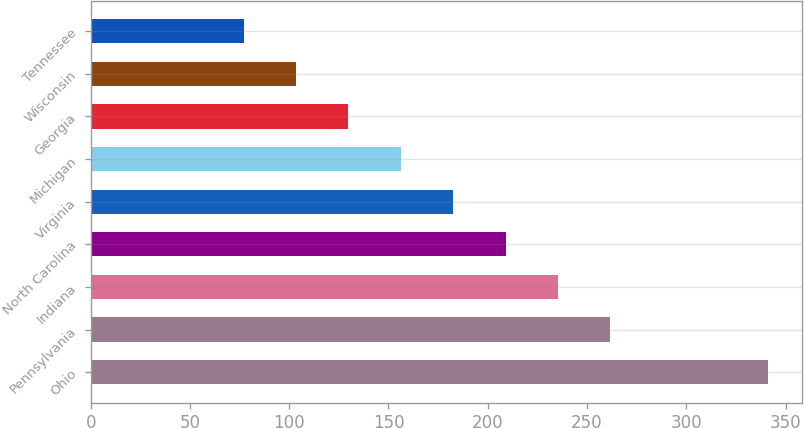Convert chart to OTSL. <chart><loc_0><loc_0><loc_500><loc_500><bar_chart><fcel>Ohio<fcel>Pennsylvania<fcel>Indiana<fcel>North Carolina<fcel>Virginia<fcel>Michigan<fcel>Georgia<fcel>Wisconsin<fcel>Tennessee<nl><fcel>341<fcel>261.8<fcel>235.4<fcel>209<fcel>182.6<fcel>156.2<fcel>129.8<fcel>103.4<fcel>77<nl></chart> 